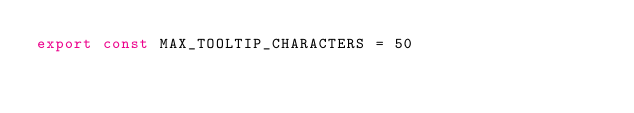<code> <loc_0><loc_0><loc_500><loc_500><_JavaScript_>export const MAX_TOOLTIP_CHARACTERS = 50
</code> 